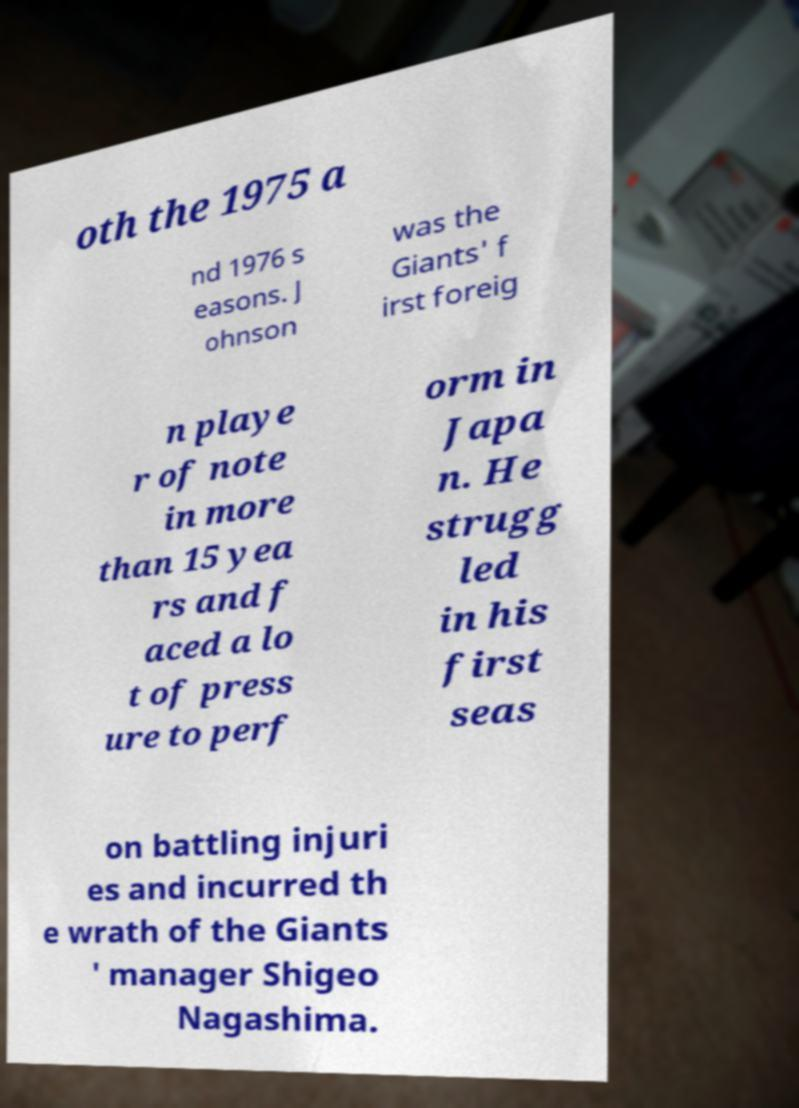Could you extract and type out the text from this image? oth the 1975 a nd 1976 s easons. J ohnson was the Giants' f irst foreig n playe r of note in more than 15 yea rs and f aced a lo t of press ure to perf orm in Japa n. He strugg led in his first seas on battling injuri es and incurred th e wrath of the Giants ' manager Shigeo Nagashima. 